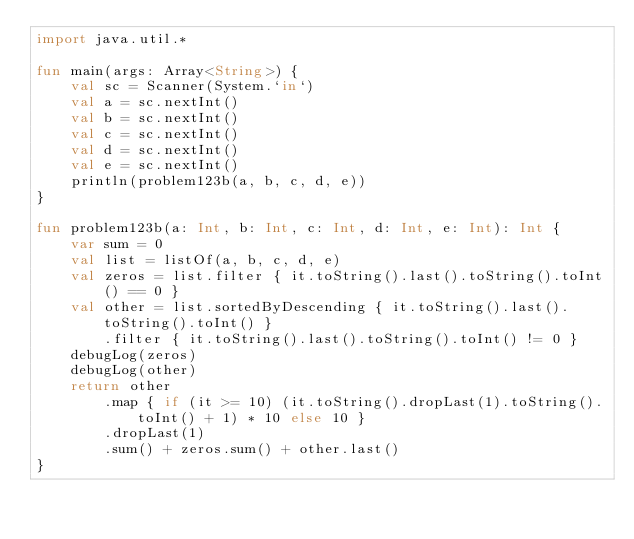Convert code to text. <code><loc_0><loc_0><loc_500><loc_500><_Kotlin_>import java.util.*

fun main(args: Array<String>) {
    val sc = Scanner(System.`in`)
    val a = sc.nextInt()
    val b = sc.nextInt()
    val c = sc.nextInt()
    val d = sc.nextInt()
    val e = sc.nextInt()
    println(problem123b(a, b, c, d, e))
}

fun problem123b(a: Int, b: Int, c: Int, d: Int, e: Int): Int {
    var sum = 0
    val list = listOf(a, b, c, d, e)
    val zeros = list.filter { it.toString().last().toString().toInt() == 0 }
    val other = list.sortedByDescending { it.toString().last().toString().toInt() }
        .filter { it.toString().last().toString().toInt() != 0 }
    debugLog(zeros)
    debugLog(other)
    return other
        .map { if (it >= 10) (it.toString().dropLast(1).toString().toInt() + 1) * 10 else 10 }
        .dropLast(1)
        .sum() + zeros.sum() + other.last()
}</code> 